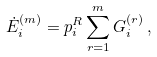Convert formula to latex. <formula><loc_0><loc_0><loc_500><loc_500>\dot { E } _ { i } ^ { ( m ) } = p _ { i } ^ { R } \sum _ { r = 1 } ^ { m } G _ { i } ^ { ( r ) } \, ,</formula> 